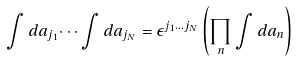Convert formula to latex. <formula><loc_0><loc_0><loc_500><loc_500>\int d a _ { j _ { 1 } } \dots \int d a _ { j _ { N } } = \epsilon ^ { j _ { 1 } \dots j _ { N } } \left ( \prod _ { n } \int d a _ { n } \right )</formula> 